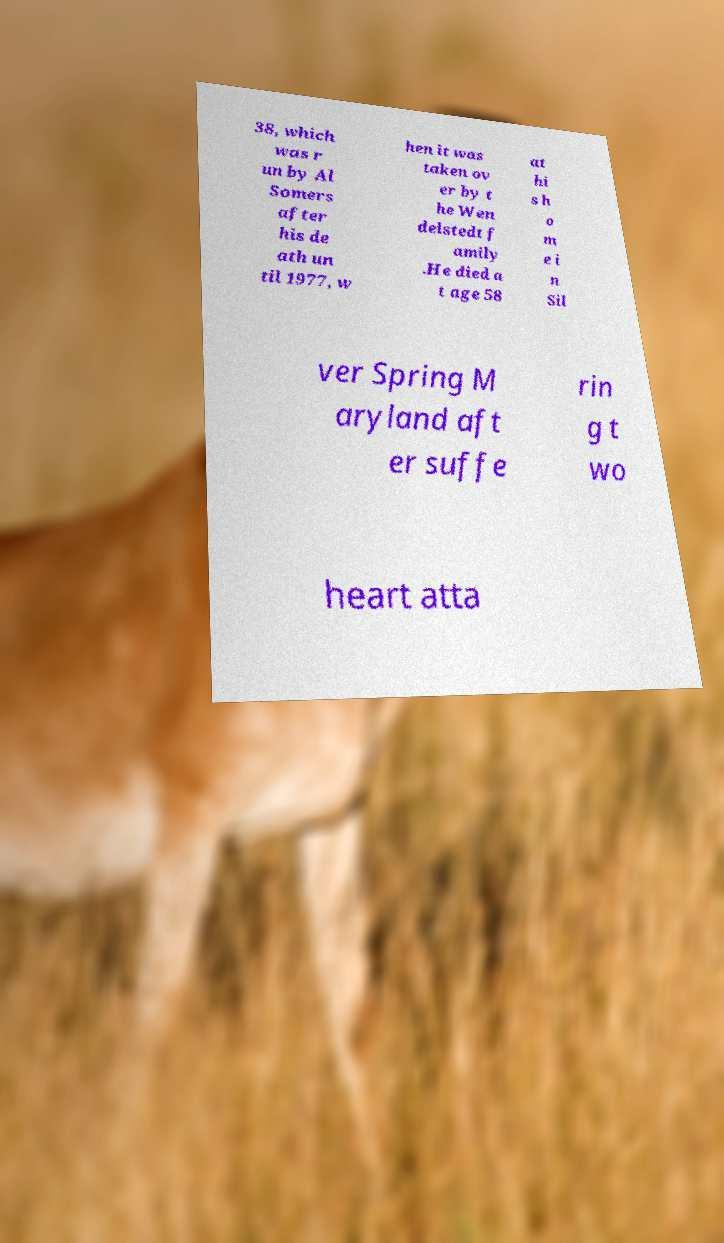Can you accurately transcribe the text from the provided image for me? 38, which was r un by Al Somers after his de ath un til 1977, w hen it was taken ov er by t he Wen delstedt f amily .He died a t age 58 at hi s h o m e i n Sil ver Spring M aryland aft er suffe rin g t wo heart atta 